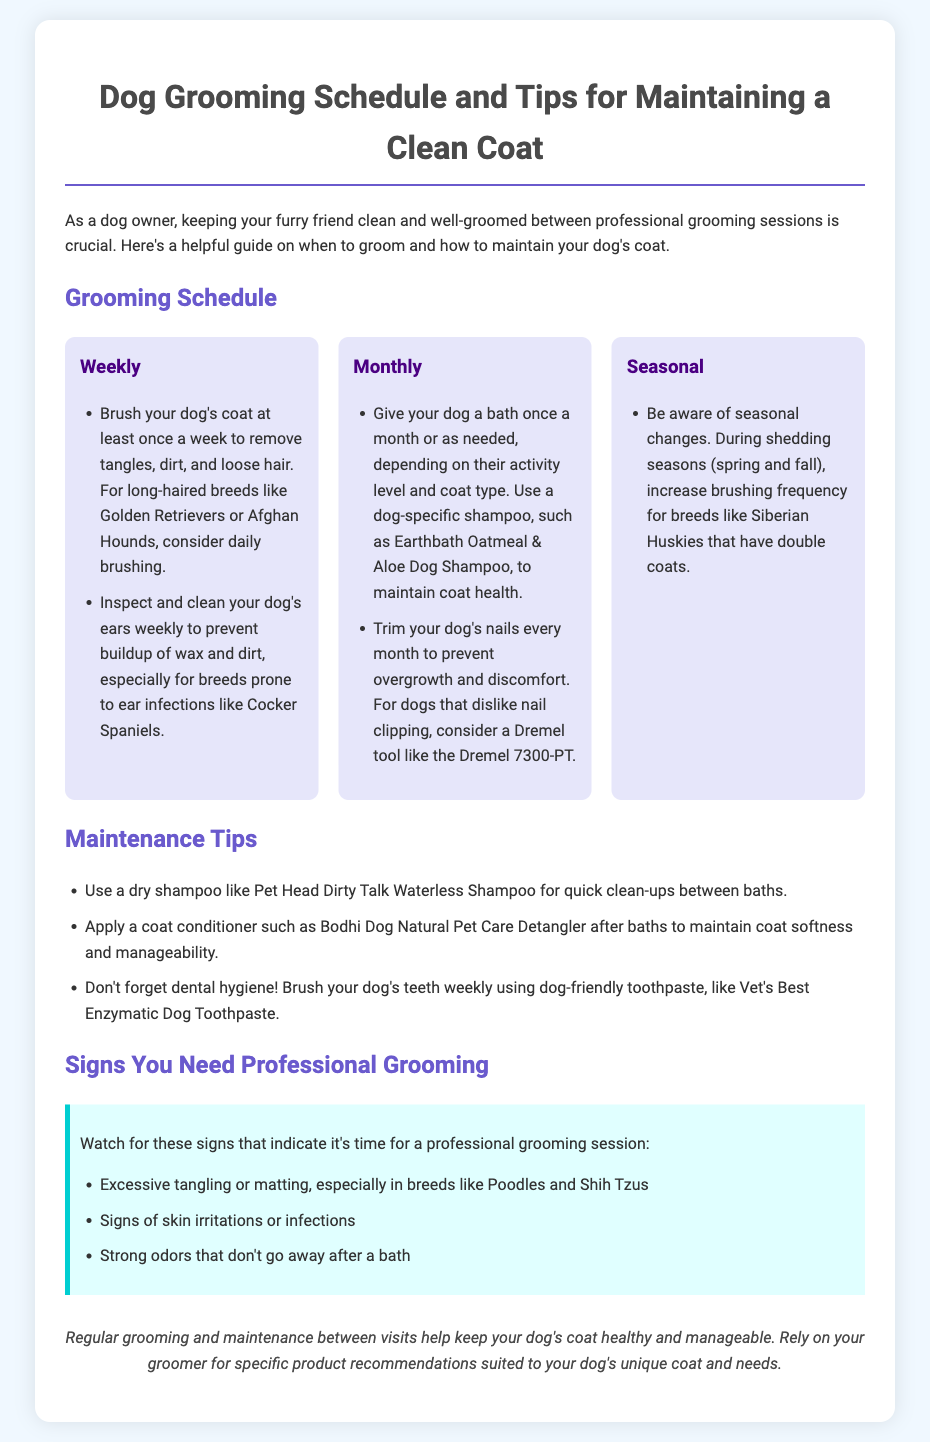What is the recommended brush frequency for long-haired breeds? Long-haired breeds like Golden Retrievers or Afghan Hounds should be brushed daily to remove tangles, dirt, and loose hair.
Answer: daily How often should you bathe your dog? It is recommended to bathe your dog once a month or as needed, depending on their activity level and coat type.
Answer: once a month What is a good dog-specific shampoo mentioned in the document? The document suggests using Earthbath Oatmeal & Aloe Dog Shampoo to maintain coat health.
Answer: Earthbath Oatmeal & Aloe Dog Shampoo What tool can be used for dogs that dislike nail clipping? The Dremel tool like the Dremel 7300-PT is suggested for dogs that dislike nail clipping.
Answer: Dremel 7300-PT During which seasons should brushing frequency be increased? Brushing frequency should be increased during shedding seasons, which are spring and fall.
Answer: spring and fall What are signs that indicate professional grooming is needed? Excessive tangling or matting, signs of skin irritations or infections, or strong odors that don't go away after a bath are indicators for professional grooming.
Answer: Excessive tangling or matting What maintenance product can be used for quick clean-ups? A dry shampoo like Pet Head Dirty Talk Waterless Shampoo is recommended for quick clean-ups between baths.
Answer: Pet Head Dirty Talk Waterless Shampoo What color is the tip box in the document? The tip box has a background color of light cyan (e0ffff).
Answer: light cyan 